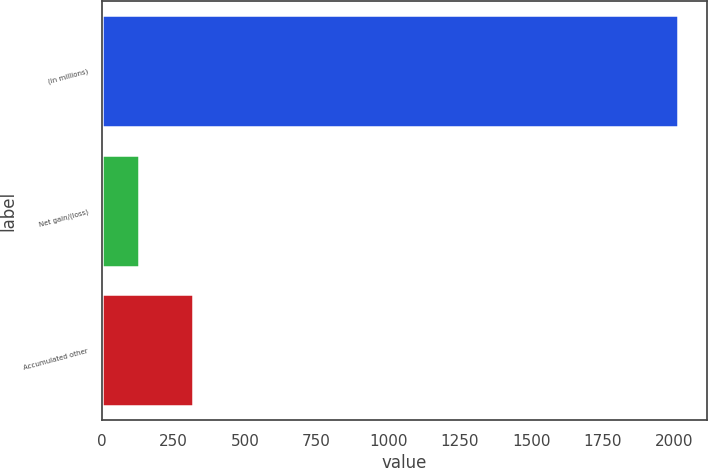<chart> <loc_0><loc_0><loc_500><loc_500><bar_chart><fcel>(in millions)<fcel>Net gain/(loss)<fcel>Accumulated other<nl><fcel>2014<fcel>130<fcel>318.4<nl></chart> 